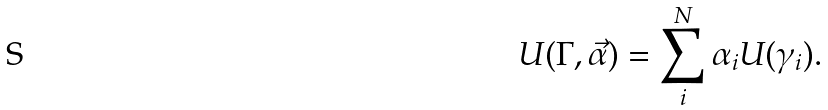<formula> <loc_0><loc_0><loc_500><loc_500>U ( \Gamma , \vec { \alpha } ) = \sum _ { i } ^ { N } \alpha _ { i } U ( \gamma _ { i } ) .</formula> 